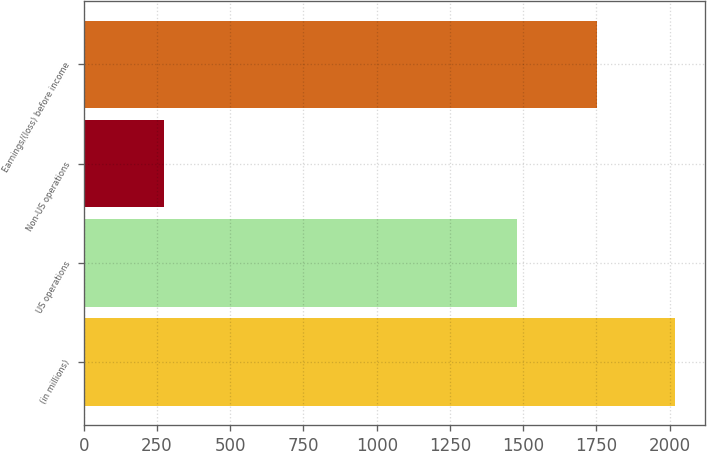Convert chart to OTSL. <chart><loc_0><loc_0><loc_500><loc_500><bar_chart><fcel>(in millions)<fcel>US operations<fcel>Non-US operations<fcel>Earnings/(loss) before income<nl><fcel>2019<fcel>1478<fcel>273<fcel>1751<nl></chart> 